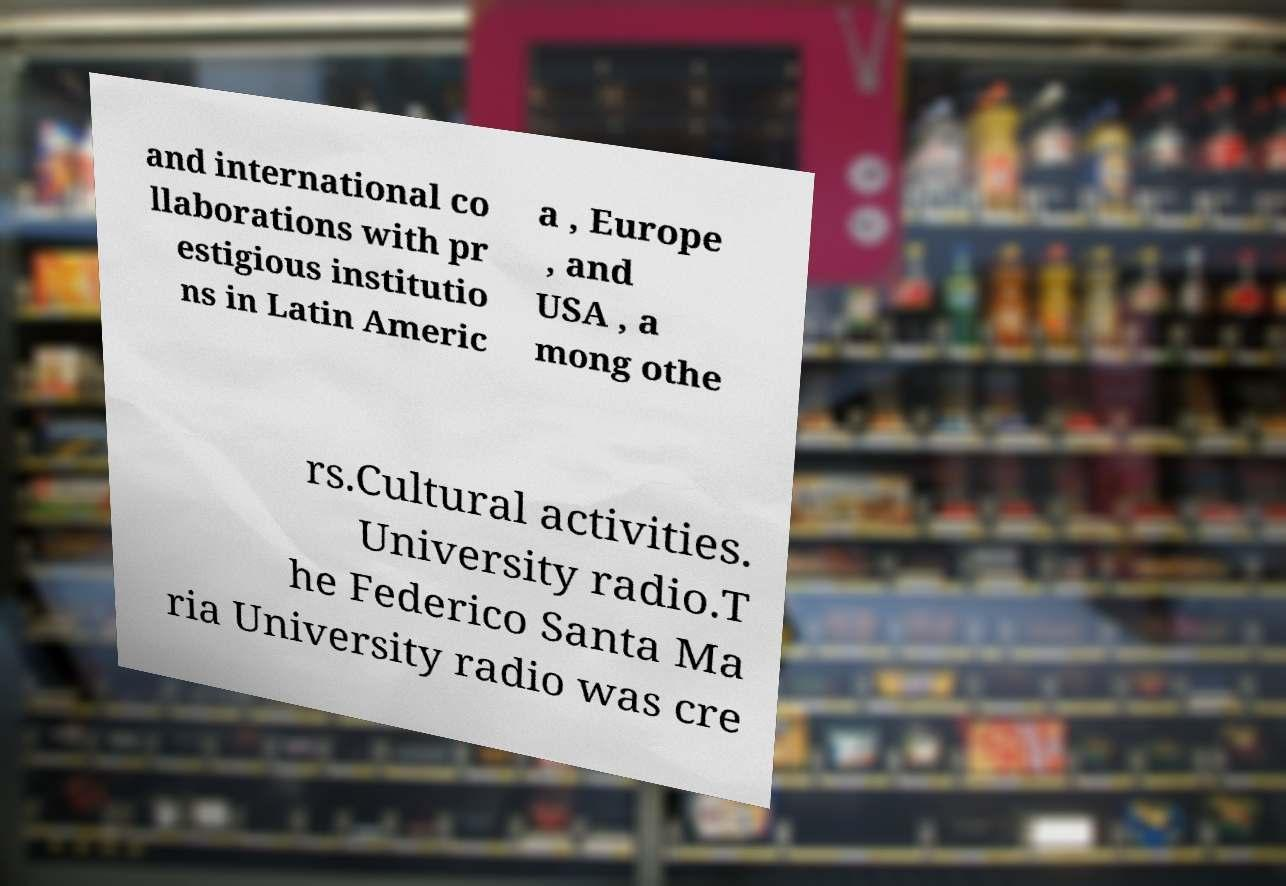Can you accurately transcribe the text from the provided image for me? and international co llaborations with pr estigious institutio ns in Latin Americ a , Europe , and USA , a mong othe rs.Cultural activities. University radio.T he Federico Santa Ma ria University radio was cre 